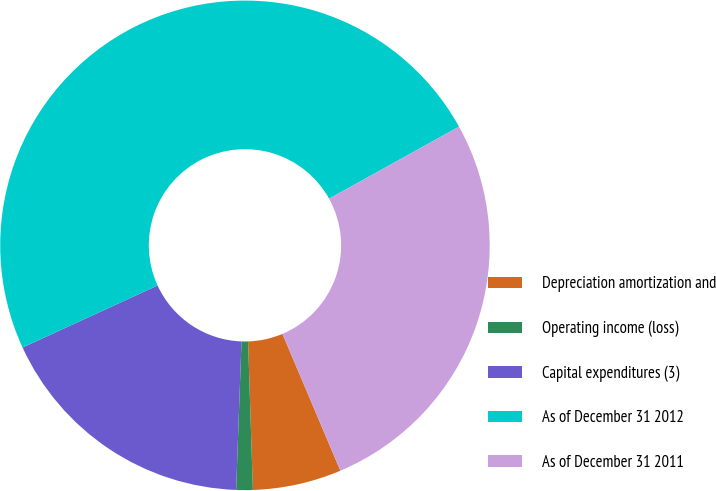<chart> <loc_0><loc_0><loc_500><loc_500><pie_chart><fcel>Depreciation amortization and<fcel>Operating income (loss)<fcel>Capital expenditures (3)<fcel>As of December 31 2012<fcel>As of December 31 2011<nl><fcel>5.86%<fcel>1.09%<fcel>17.57%<fcel>48.8%<fcel>26.68%<nl></chart> 